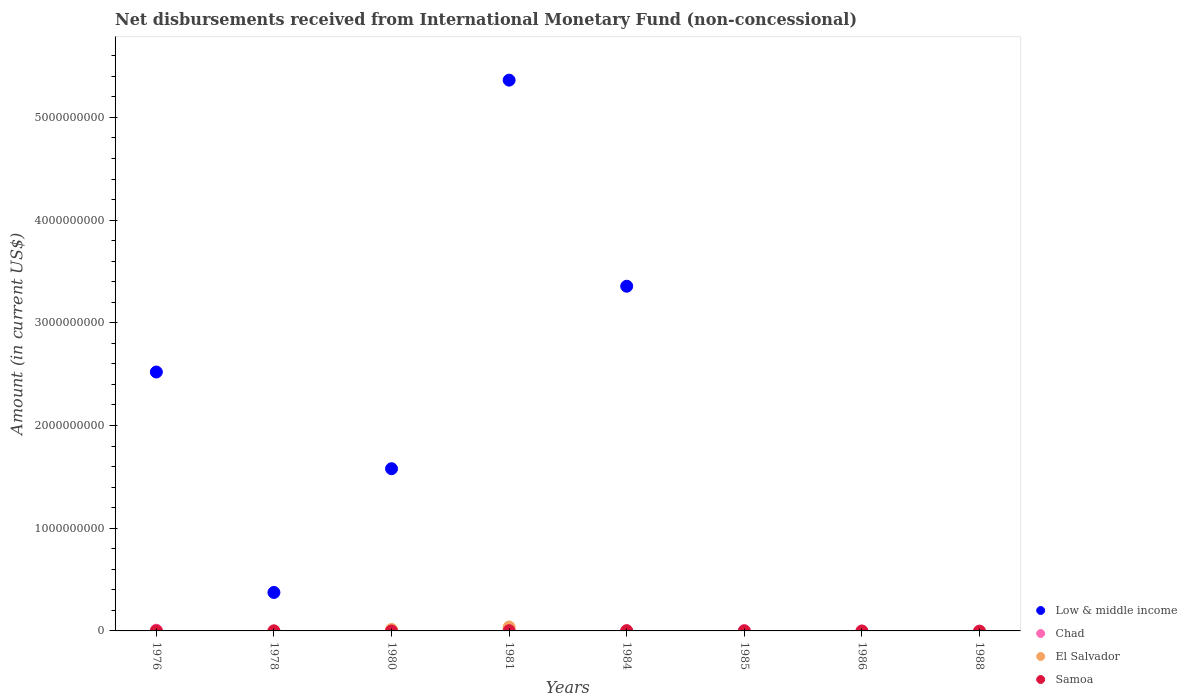How many different coloured dotlines are there?
Provide a succinct answer. 4. Is the number of dotlines equal to the number of legend labels?
Your response must be concise. No. Across all years, what is the maximum amount of disbursements received from International Monetary Fund in El Salvador?
Keep it short and to the point. 3.80e+07. Across all years, what is the minimum amount of disbursements received from International Monetary Fund in Chad?
Make the answer very short. 0. In which year was the amount of disbursements received from International Monetary Fund in El Salvador maximum?
Provide a short and direct response. 1981. What is the total amount of disbursements received from International Monetary Fund in El Salvador in the graph?
Give a very brief answer. 5.21e+07. What is the difference between the amount of disbursements received from International Monetary Fund in Low & middle income in 1981 and that in 1984?
Your answer should be very brief. 2.01e+09. What is the difference between the amount of disbursements received from International Monetary Fund in Samoa in 1985 and the amount of disbursements received from International Monetary Fund in Low & middle income in 1986?
Make the answer very short. 3.20e+05. What is the average amount of disbursements received from International Monetary Fund in Low & middle income per year?
Your response must be concise. 1.65e+09. In the year 1976, what is the difference between the amount of disbursements received from International Monetary Fund in Samoa and amount of disbursements received from International Monetary Fund in Chad?
Ensure brevity in your answer.  -6.84e+06. In how many years, is the amount of disbursements received from International Monetary Fund in El Salvador greater than 1600000000 US$?
Give a very brief answer. 0. What is the difference between the highest and the second highest amount of disbursements received from International Monetary Fund in Low & middle income?
Ensure brevity in your answer.  2.01e+09. What is the difference between the highest and the lowest amount of disbursements received from International Monetary Fund in El Salvador?
Your answer should be very brief. 3.80e+07. In how many years, is the amount of disbursements received from International Monetary Fund in Samoa greater than the average amount of disbursements received from International Monetary Fund in Samoa taken over all years?
Ensure brevity in your answer.  3. Is the sum of the amount of disbursements received from International Monetary Fund in Low & middle income in 1976 and 1984 greater than the maximum amount of disbursements received from International Monetary Fund in El Salvador across all years?
Provide a short and direct response. Yes. Is it the case that in every year, the sum of the amount of disbursements received from International Monetary Fund in El Salvador and amount of disbursements received from International Monetary Fund in Low & middle income  is greater than the sum of amount of disbursements received from International Monetary Fund in Chad and amount of disbursements received from International Monetary Fund in Samoa?
Give a very brief answer. No. Does the amount of disbursements received from International Monetary Fund in Samoa monotonically increase over the years?
Keep it short and to the point. No. Is the amount of disbursements received from International Monetary Fund in El Salvador strictly greater than the amount of disbursements received from International Monetary Fund in Low & middle income over the years?
Provide a succinct answer. No. Is the amount of disbursements received from International Monetary Fund in El Salvador strictly less than the amount of disbursements received from International Monetary Fund in Low & middle income over the years?
Ensure brevity in your answer.  No. How many dotlines are there?
Give a very brief answer. 4. How many years are there in the graph?
Your answer should be compact. 8. What is the difference between two consecutive major ticks on the Y-axis?
Make the answer very short. 1.00e+09. Are the values on the major ticks of Y-axis written in scientific E-notation?
Your answer should be very brief. No. Where does the legend appear in the graph?
Ensure brevity in your answer.  Bottom right. How many legend labels are there?
Keep it short and to the point. 4. What is the title of the graph?
Give a very brief answer. Net disbursements received from International Monetary Fund (non-concessional). Does "Chad" appear as one of the legend labels in the graph?
Make the answer very short. Yes. What is the label or title of the X-axis?
Provide a short and direct response. Years. What is the label or title of the Y-axis?
Provide a succinct answer. Amount (in current US$). What is the Amount (in current US$) in Low & middle income in 1976?
Your answer should be very brief. 2.52e+09. What is the Amount (in current US$) in Chad in 1976?
Keep it short and to the point. 7.50e+06. What is the Amount (in current US$) in El Salvador in 1976?
Provide a succinct answer. 0. What is the Amount (in current US$) of Low & middle income in 1978?
Give a very brief answer. 3.74e+08. What is the Amount (in current US$) of Samoa in 1978?
Offer a very short reply. 8.74e+05. What is the Amount (in current US$) in Low & middle income in 1980?
Keep it short and to the point. 1.58e+09. What is the Amount (in current US$) of Chad in 1980?
Make the answer very short. 0. What is the Amount (in current US$) of El Salvador in 1980?
Your response must be concise. 1.41e+07. What is the Amount (in current US$) of Samoa in 1980?
Ensure brevity in your answer.  0. What is the Amount (in current US$) of Low & middle income in 1981?
Keep it short and to the point. 5.36e+09. What is the Amount (in current US$) of El Salvador in 1981?
Give a very brief answer. 3.80e+07. What is the Amount (in current US$) of Samoa in 1981?
Ensure brevity in your answer.  2.20e+06. What is the Amount (in current US$) in Low & middle income in 1984?
Your answer should be very brief. 3.36e+09. What is the Amount (in current US$) of Samoa in 1984?
Ensure brevity in your answer.  2.70e+06. What is the Amount (in current US$) in Low & middle income in 1985?
Give a very brief answer. 0. What is the Amount (in current US$) of Chad in 1985?
Keep it short and to the point. 3.50e+06. What is the Amount (in current US$) in El Salvador in 1985?
Offer a very short reply. 0. What is the Amount (in current US$) of Samoa in 1986?
Give a very brief answer. 0. What is the Amount (in current US$) of Chad in 1988?
Make the answer very short. 0. What is the Amount (in current US$) in El Salvador in 1988?
Keep it short and to the point. 0. Across all years, what is the maximum Amount (in current US$) of Low & middle income?
Your response must be concise. 5.36e+09. Across all years, what is the maximum Amount (in current US$) in Chad?
Offer a terse response. 7.50e+06. Across all years, what is the maximum Amount (in current US$) in El Salvador?
Offer a terse response. 3.80e+07. Across all years, what is the maximum Amount (in current US$) in Samoa?
Offer a terse response. 2.70e+06. Across all years, what is the minimum Amount (in current US$) of Low & middle income?
Your answer should be compact. 0. Across all years, what is the minimum Amount (in current US$) of El Salvador?
Ensure brevity in your answer.  0. What is the total Amount (in current US$) in Low & middle income in the graph?
Your answer should be compact. 1.32e+1. What is the total Amount (in current US$) of Chad in the graph?
Provide a short and direct response. 1.30e+07. What is the total Amount (in current US$) of El Salvador in the graph?
Offer a very short reply. 5.21e+07. What is the total Amount (in current US$) in Samoa in the graph?
Keep it short and to the point. 6.75e+06. What is the difference between the Amount (in current US$) of Low & middle income in 1976 and that in 1978?
Ensure brevity in your answer.  2.15e+09. What is the difference between the Amount (in current US$) in Samoa in 1976 and that in 1978?
Your response must be concise. -2.14e+05. What is the difference between the Amount (in current US$) of Low & middle income in 1976 and that in 1980?
Provide a short and direct response. 9.41e+08. What is the difference between the Amount (in current US$) of Low & middle income in 1976 and that in 1981?
Offer a very short reply. -2.84e+09. What is the difference between the Amount (in current US$) of Chad in 1976 and that in 1981?
Give a very brief answer. 5.50e+06. What is the difference between the Amount (in current US$) of Samoa in 1976 and that in 1981?
Offer a terse response. -1.54e+06. What is the difference between the Amount (in current US$) of Low & middle income in 1976 and that in 1984?
Provide a short and direct response. -8.35e+08. What is the difference between the Amount (in current US$) in Samoa in 1976 and that in 1984?
Your response must be concise. -2.04e+06. What is the difference between the Amount (in current US$) of Chad in 1976 and that in 1985?
Provide a succinct answer. 4.00e+06. What is the difference between the Amount (in current US$) of Low & middle income in 1978 and that in 1980?
Make the answer very short. -1.20e+09. What is the difference between the Amount (in current US$) in Low & middle income in 1978 and that in 1981?
Provide a succinct answer. -4.99e+09. What is the difference between the Amount (in current US$) in Samoa in 1978 and that in 1981?
Offer a very short reply. -1.33e+06. What is the difference between the Amount (in current US$) of Low & middle income in 1978 and that in 1984?
Ensure brevity in your answer.  -2.98e+09. What is the difference between the Amount (in current US$) in Samoa in 1978 and that in 1984?
Provide a short and direct response. -1.83e+06. What is the difference between the Amount (in current US$) in Samoa in 1978 and that in 1985?
Your answer should be compact. 5.54e+05. What is the difference between the Amount (in current US$) of Low & middle income in 1980 and that in 1981?
Offer a terse response. -3.78e+09. What is the difference between the Amount (in current US$) of El Salvador in 1980 and that in 1981?
Make the answer very short. -2.39e+07. What is the difference between the Amount (in current US$) of Low & middle income in 1980 and that in 1984?
Ensure brevity in your answer.  -1.78e+09. What is the difference between the Amount (in current US$) of Low & middle income in 1981 and that in 1984?
Ensure brevity in your answer.  2.01e+09. What is the difference between the Amount (in current US$) in Samoa in 1981 and that in 1984?
Offer a terse response. -5.00e+05. What is the difference between the Amount (in current US$) in Chad in 1981 and that in 1985?
Ensure brevity in your answer.  -1.50e+06. What is the difference between the Amount (in current US$) of Samoa in 1981 and that in 1985?
Offer a very short reply. 1.88e+06. What is the difference between the Amount (in current US$) of Samoa in 1984 and that in 1985?
Your response must be concise. 2.38e+06. What is the difference between the Amount (in current US$) of Low & middle income in 1976 and the Amount (in current US$) of Samoa in 1978?
Offer a terse response. 2.52e+09. What is the difference between the Amount (in current US$) in Chad in 1976 and the Amount (in current US$) in Samoa in 1978?
Provide a short and direct response. 6.63e+06. What is the difference between the Amount (in current US$) in Low & middle income in 1976 and the Amount (in current US$) in El Salvador in 1980?
Keep it short and to the point. 2.51e+09. What is the difference between the Amount (in current US$) of Chad in 1976 and the Amount (in current US$) of El Salvador in 1980?
Your answer should be very brief. -6.60e+06. What is the difference between the Amount (in current US$) of Low & middle income in 1976 and the Amount (in current US$) of Chad in 1981?
Keep it short and to the point. 2.52e+09. What is the difference between the Amount (in current US$) of Low & middle income in 1976 and the Amount (in current US$) of El Salvador in 1981?
Provide a succinct answer. 2.48e+09. What is the difference between the Amount (in current US$) in Low & middle income in 1976 and the Amount (in current US$) in Samoa in 1981?
Ensure brevity in your answer.  2.52e+09. What is the difference between the Amount (in current US$) in Chad in 1976 and the Amount (in current US$) in El Salvador in 1981?
Offer a very short reply. -3.05e+07. What is the difference between the Amount (in current US$) in Chad in 1976 and the Amount (in current US$) in Samoa in 1981?
Provide a short and direct response. 5.30e+06. What is the difference between the Amount (in current US$) in Low & middle income in 1976 and the Amount (in current US$) in Samoa in 1984?
Make the answer very short. 2.52e+09. What is the difference between the Amount (in current US$) of Chad in 1976 and the Amount (in current US$) of Samoa in 1984?
Offer a terse response. 4.80e+06. What is the difference between the Amount (in current US$) in Low & middle income in 1976 and the Amount (in current US$) in Chad in 1985?
Give a very brief answer. 2.52e+09. What is the difference between the Amount (in current US$) of Low & middle income in 1976 and the Amount (in current US$) of Samoa in 1985?
Offer a very short reply. 2.52e+09. What is the difference between the Amount (in current US$) of Chad in 1976 and the Amount (in current US$) of Samoa in 1985?
Your answer should be very brief. 7.18e+06. What is the difference between the Amount (in current US$) of Low & middle income in 1978 and the Amount (in current US$) of El Salvador in 1980?
Your answer should be very brief. 3.60e+08. What is the difference between the Amount (in current US$) of Low & middle income in 1978 and the Amount (in current US$) of Chad in 1981?
Provide a succinct answer. 3.72e+08. What is the difference between the Amount (in current US$) of Low & middle income in 1978 and the Amount (in current US$) of El Salvador in 1981?
Give a very brief answer. 3.36e+08. What is the difference between the Amount (in current US$) of Low & middle income in 1978 and the Amount (in current US$) of Samoa in 1981?
Your answer should be very brief. 3.72e+08. What is the difference between the Amount (in current US$) in Low & middle income in 1978 and the Amount (in current US$) in Samoa in 1984?
Your response must be concise. 3.72e+08. What is the difference between the Amount (in current US$) of Low & middle income in 1978 and the Amount (in current US$) of Chad in 1985?
Give a very brief answer. 3.71e+08. What is the difference between the Amount (in current US$) in Low & middle income in 1978 and the Amount (in current US$) in Samoa in 1985?
Your response must be concise. 3.74e+08. What is the difference between the Amount (in current US$) in Low & middle income in 1980 and the Amount (in current US$) in Chad in 1981?
Offer a very short reply. 1.58e+09. What is the difference between the Amount (in current US$) in Low & middle income in 1980 and the Amount (in current US$) in El Salvador in 1981?
Keep it short and to the point. 1.54e+09. What is the difference between the Amount (in current US$) of Low & middle income in 1980 and the Amount (in current US$) of Samoa in 1981?
Offer a very short reply. 1.58e+09. What is the difference between the Amount (in current US$) in El Salvador in 1980 and the Amount (in current US$) in Samoa in 1981?
Your answer should be compact. 1.19e+07. What is the difference between the Amount (in current US$) in Low & middle income in 1980 and the Amount (in current US$) in Samoa in 1984?
Keep it short and to the point. 1.58e+09. What is the difference between the Amount (in current US$) in El Salvador in 1980 and the Amount (in current US$) in Samoa in 1984?
Offer a terse response. 1.14e+07. What is the difference between the Amount (in current US$) of Low & middle income in 1980 and the Amount (in current US$) of Chad in 1985?
Your answer should be very brief. 1.58e+09. What is the difference between the Amount (in current US$) in Low & middle income in 1980 and the Amount (in current US$) in Samoa in 1985?
Provide a short and direct response. 1.58e+09. What is the difference between the Amount (in current US$) of El Salvador in 1980 and the Amount (in current US$) of Samoa in 1985?
Give a very brief answer. 1.38e+07. What is the difference between the Amount (in current US$) in Low & middle income in 1981 and the Amount (in current US$) in Samoa in 1984?
Your answer should be very brief. 5.36e+09. What is the difference between the Amount (in current US$) of Chad in 1981 and the Amount (in current US$) of Samoa in 1984?
Your answer should be very brief. -7.00e+05. What is the difference between the Amount (in current US$) in El Salvador in 1981 and the Amount (in current US$) in Samoa in 1984?
Offer a terse response. 3.53e+07. What is the difference between the Amount (in current US$) in Low & middle income in 1981 and the Amount (in current US$) in Chad in 1985?
Provide a short and direct response. 5.36e+09. What is the difference between the Amount (in current US$) in Low & middle income in 1981 and the Amount (in current US$) in Samoa in 1985?
Give a very brief answer. 5.36e+09. What is the difference between the Amount (in current US$) of Chad in 1981 and the Amount (in current US$) of Samoa in 1985?
Ensure brevity in your answer.  1.68e+06. What is the difference between the Amount (in current US$) of El Salvador in 1981 and the Amount (in current US$) of Samoa in 1985?
Offer a terse response. 3.77e+07. What is the difference between the Amount (in current US$) in Low & middle income in 1984 and the Amount (in current US$) in Chad in 1985?
Your response must be concise. 3.35e+09. What is the difference between the Amount (in current US$) in Low & middle income in 1984 and the Amount (in current US$) in Samoa in 1985?
Provide a short and direct response. 3.36e+09. What is the average Amount (in current US$) in Low & middle income per year?
Your answer should be compact. 1.65e+09. What is the average Amount (in current US$) in Chad per year?
Ensure brevity in your answer.  1.63e+06. What is the average Amount (in current US$) in El Salvador per year?
Offer a very short reply. 6.51e+06. What is the average Amount (in current US$) of Samoa per year?
Make the answer very short. 8.44e+05. In the year 1976, what is the difference between the Amount (in current US$) of Low & middle income and Amount (in current US$) of Chad?
Keep it short and to the point. 2.51e+09. In the year 1976, what is the difference between the Amount (in current US$) of Low & middle income and Amount (in current US$) of Samoa?
Keep it short and to the point. 2.52e+09. In the year 1976, what is the difference between the Amount (in current US$) of Chad and Amount (in current US$) of Samoa?
Provide a short and direct response. 6.84e+06. In the year 1978, what is the difference between the Amount (in current US$) of Low & middle income and Amount (in current US$) of Samoa?
Make the answer very short. 3.74e+08. In the year 1980, what is the difference between the Amount (in current US$) in Low & middle income and Amount (in current US$) in El Salvador?
Your response must be concise. 1.57e+09. In the year 1981, what is the difference between the Amount (in current US$) of Low & middle income and Amount (in current US$) of Chad?
Give a very brief answer. 5.36e+09. In the year 1981, what is the difference between the Amount (in current US$) in Low & middle income and Amount (in current US$) in El Salvador?
Offer a terse response. 5.32e+09. In the year 1981, what is the difference between the Amount (in current US$) of Low & middle income and Amount (in current US$) of Samoa?
Provide a short and direct response. 5.36e+09. In the year 1981, what is the difference between the Amount (in current US$) in Chad and Amount (in current US$) in El Salvador?
Give a very brief answer. -3.60e+07. In the year 1981, what is the difference between the Amount (in current US$) in Chad and Amount (in current US$) in Samoa?
Provide a short and direct response. -2.00e+05. In the year 1981, what is the difference between the Amount (in current US$) in El Salvador and Amount (in current US$) in Samoa?
Your answer should be very brief. 3.58e+07. In the year 1984, what is the difference between the Amount (in current US$) of Low & middle income and Amount (in current US$) of Samoa?
Ensure brevity in your answer.  3.35e+09. In the year 1985, what is the difference between the Amount (in current US$) in Chad and Amount (in current US$) in Samoa?
Offer a very short reply. 3.18e+06. What is the ratio of the Amount (in current US$) in Low & middle income in 1976 to that in 1978?
Ensure brevity in your answer.  6.73. What is the ratio of the Amount (in current US$) in Samoa in 1976 to that in 1978?
Give a very brief answer. 0.76. What is the ratio of the Amount (in current US$) of Low & middle income in 1976 to that in 1980?
Your response must be concise. 1.6. What is the ratio of the Amount (in current US$) of Low & middle income in 1976 to that in 1981?
Ensure brevity in your answer.  0.47. What is the ratio of the Amount (in current US$) in Chad in 1976 to that in 1981?
Keep it short and to the point. 3.75. What is the ratio of the Amount (in current US$) of Samoa in 1976 to that in 1981?
Offer a terse response. 0.3. What is the ratio of the Amount (in current US$) of Low & middle income in 1976 to that in 1984?
Keep it short and to the point. 0.75. What is the ratio of the Amount (in current US$) in Samoa in 1976 to that in 1984?
Make the answer very short. 0.24. What is the ratio of the Amount (in current US$) of Chad in 1976 to that in 1985?
Make the answer very short. 2.14. What is the ratio of the Amount (in current US$) of Samoa in 1976 to that in 1985?
Provide a succinct answer. 2.06. What is the ratio of the Amount (in current US$) in Low & middle income in 1978 to that in 1980?
Your answer should be compact. 0.24. What is the ratio of the Amount (in current US$) of Low & middle income in 1978 to that in 1981?
Your answer should be compact. 0.07. What is the ratio of the Amount (in current US$) of Samoa in 1978 to that in 1981?
Offer a terse response. 0.4. What is the ratio of the Amount (in current US$) in Low & middle income in 1978 to that in 1984?
Offer a very short reply. 0.11. What is the ratio of the Amount (in current US$) in Samoa in 1978 to that in 1984?
Ensure brevity in your answer.  0.32. What is the ratio of the Amount (in current US$) of Samoa in 1978 to that in 1985?
Provide a short and direct response. 2.73. What is the ratio of the Amount (in current US$) in Low & middle income in 1980 to that in 1981?
Provide a succinct answer. 0.29. What is the ratio of the Amount (in current US$) in El Salvador in 1980 to that in 1981?
Your response must be concise. 0.37. What is the ratio of the Amount (in current US$) in Low & middle income in 1980 to that in 1984?
Keep it short and to the point. 0.47. What is the ratio of the Amount (in current US$) in Low & middle income in 1981 to that in 1984?
Provide a short and direct response. 1.6. What is the ratio of the Amount (in current US$) of Samoa in 1981 to that in 1984?
Provide a short and direct response. 0.81. What is the ratio of the Amount (in current US$) in Samoa in 1981 to that in 1985?
Make the answer very short. 6.88. What is the ratio of the Amount (in current US$) in Samoa in 1984 to that in 1985?
Offer a very short reply. 8.44. What is the difference between the highest and the second highest Amount (in current US$) of Low & middle income?
Keep it short and to the point. 2.01e+09. What is the difference between the highest and the second highest Amount (in current US$) in Chad?
Give a very brief answer. 4.00e+06. What is the difference between the highest and the second highest Amount (in current US$) in Samoa?
Your response must be concise. 5.00e+05. What is the difference between the highest and the lowest Amount (in current US$) in Low & middle income?
Your answer should be very brief. 5.36e+09. What is the difference between the highest and the lowest Amount (in current US$) of Chad?
Your response must be concise. 7.50e+06. What is the difference between the highest and the lowest Amount (in current US$) of El Salvador?
Keep it short and to the point. 3.80e+07. What is the difference between the highest and the lowest Amount (in current US$) in Samoa?
Give a very brief answer. 2.70e+06. 